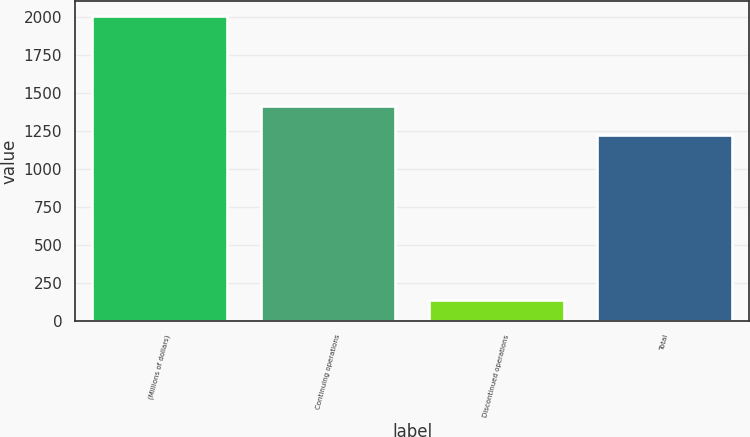Convert chart to OTSL. <chart><loc_0><loc_0><loc_500><loc_500><bar_chart><fcel>(Millions of dollars)<fcel>Continuing operations<fcel>Discontinued operations<fcel>Total<nl><fcel>2005<fcel>1412.9<fcel>136<fcel>1226<nl></chart> 